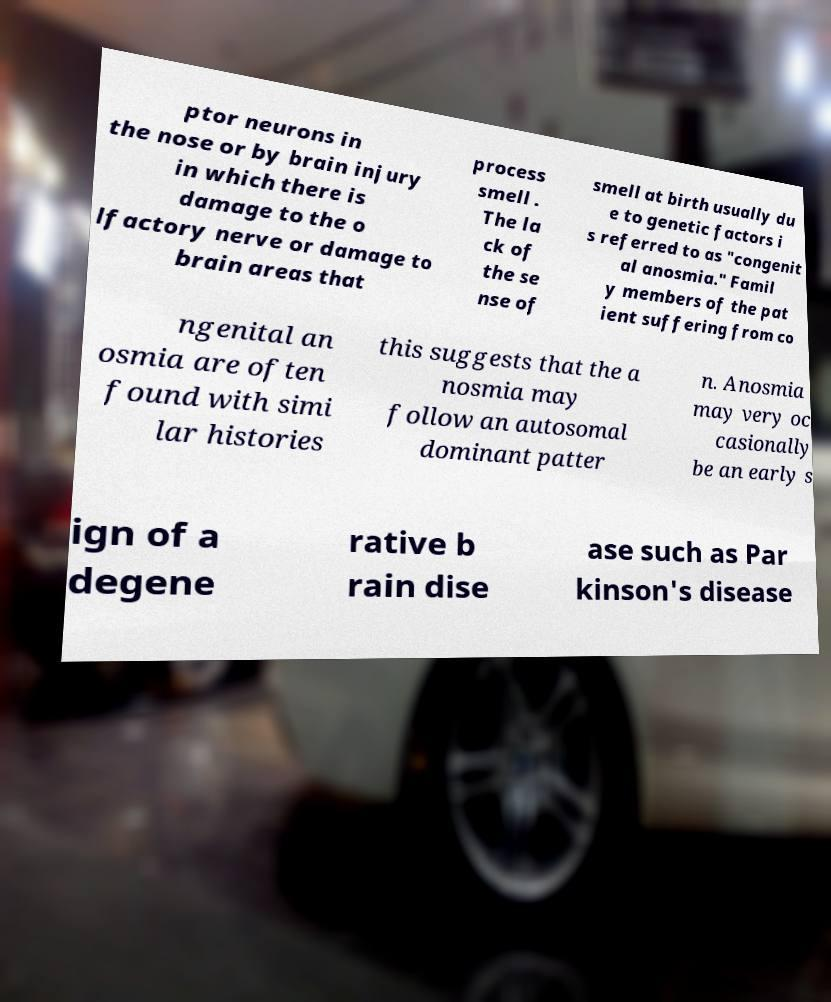Please read and relay the text visible in this image. What does it say? ptor neurons in the nose or by brain injury in which there is damage to the o lfactory nerve or damage to brain areas that process smell . The la ck of the se nse of smell at birth usually du e to genetic factors i s referred to as "congenit al anosmia." Famil y members of the pat ient suffering from co ngenital an osmia are often found with simi lar histories this suggests that the a nosmia may follow an autosomal dominant patter n. Anosmia may very oc casionally be an early s ign of a degene rative b rain dise ase such as Par kinson's disease 